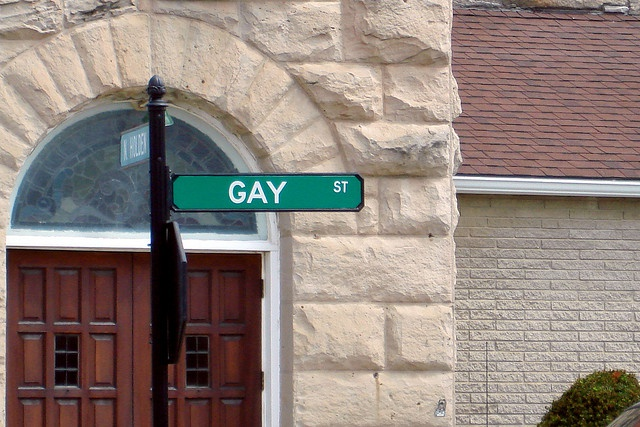Describe the objects in this image and their specific colors. I can see a stop sign in darkgray, black, and gray tones in this image. 